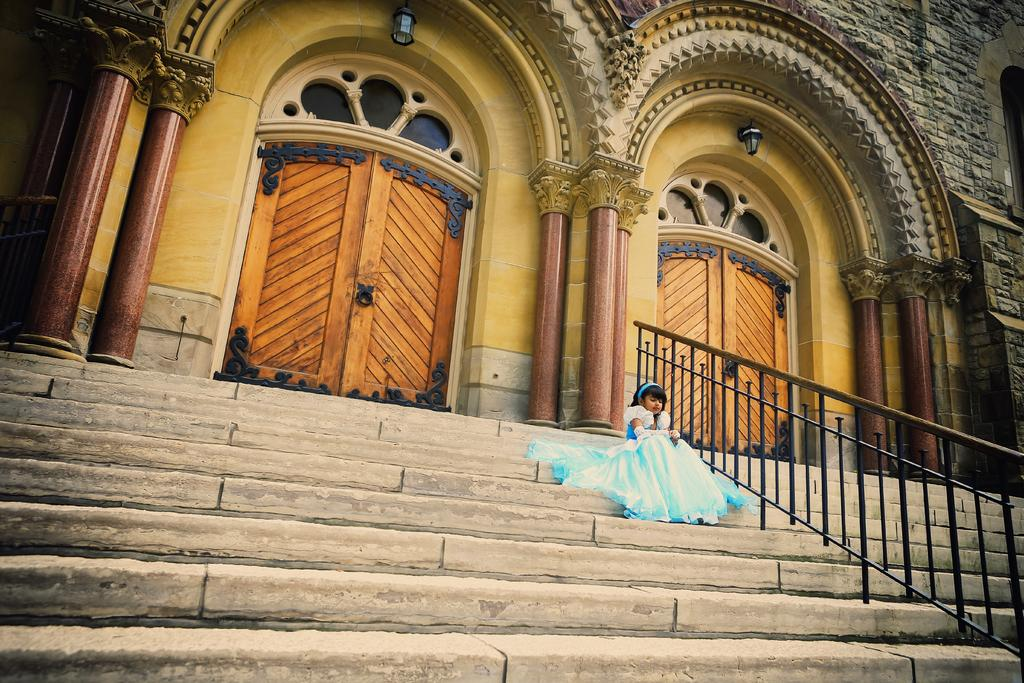Who is the main subject in the image? There is a girl in the center of the image. What is the girl doing in the image? The girl is on the stairs. What can be seen in the background of the image? There is a building in the background of the image. What is on the right side of the image? There is fencing on the right side of the image. What type of whistle can be heard in the image? There is no whistle present in the image, and therefore no sound can be heard. 